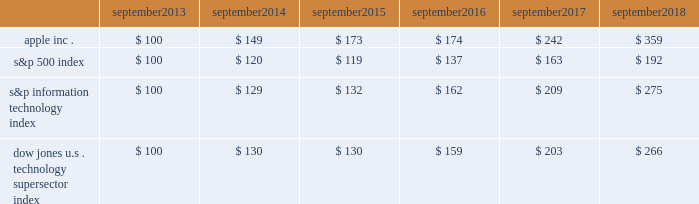Apple inc .
| 2018 form 10-k | 20 company stock performance the following graph shows a comparison of cumulative total shareholder return , calculated on a dividend-reinvested basis , for the company , the s&p 500 index , the s&p information technology index and the dow jones u.s .
Technology supersector index for the five years ended september 29 , 2018 .
The graph assumes $ 100 was invested in each of the company 2019s common stock , the s&p 500 index , the s&p information technology index and the dow jones u.s .
Technology supersector index as of the market close on september 27 , 2013 .
Note that historic stock price performance is not necessarily indicative of future stock price performance .
* $ 100 invested on september 27 , 2013 in stock or index , including reinvestment of dividends .
Data points are the last day of each fiscal year for the company 2019s common stock and september 30th for indexes .
Copyright a9 2018 standard & poor 2019s , a division of s&p global .
All rights reserved .
Copyright a9 2018 s&p dow jones indices llc , a division of s&p global .
All rights reserved .
September september september september september september .

What was the percentage cumulative total return for apple inc . for the five year period ended september 2018? 
Computations: ((359 - 100) / 100)
Answer: 2.59. 